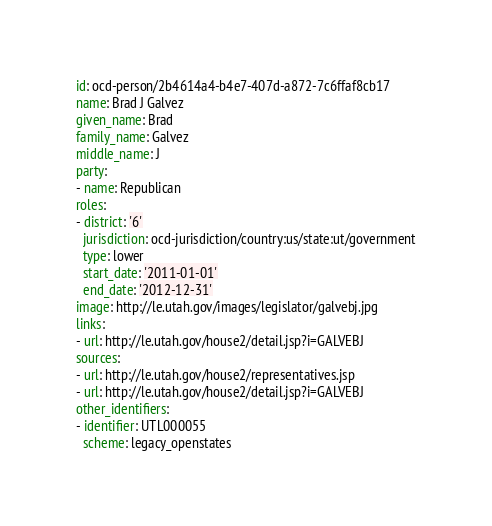Convert code to text. <code><loc_0><loc_0><loc_500><loc_500><_YAML_>id: ocd-person/2b4614a4-b4e7-407d-a872-7c6ffaf8cb17
name: Brad J Galvez
given_name: Brad
family_name: Galvez
middle_name: J
party:
- name: Republican
roles:
- district: '6'
  jurisdiction: ocd-jurisdiction/country:us/state:ut/government
  type: lower
  start_date: '2011-01-01'
  end_date: '2012-12-31'
image: http://le.utah.gov/images/legislator/galvebj.jpg
links:
- url: http://le.utah.gov/house2/detail.jsp?i=GALVEBJ
sources:
- url: http://le.utah.gov/house2/representatives.jsp
- url: http://le.utah.gov/house2/detail.jsp?i=GALVEBJ
other_identifiers:
- identifier: UTL000055
  scheme: legacy_openstates
</code> 